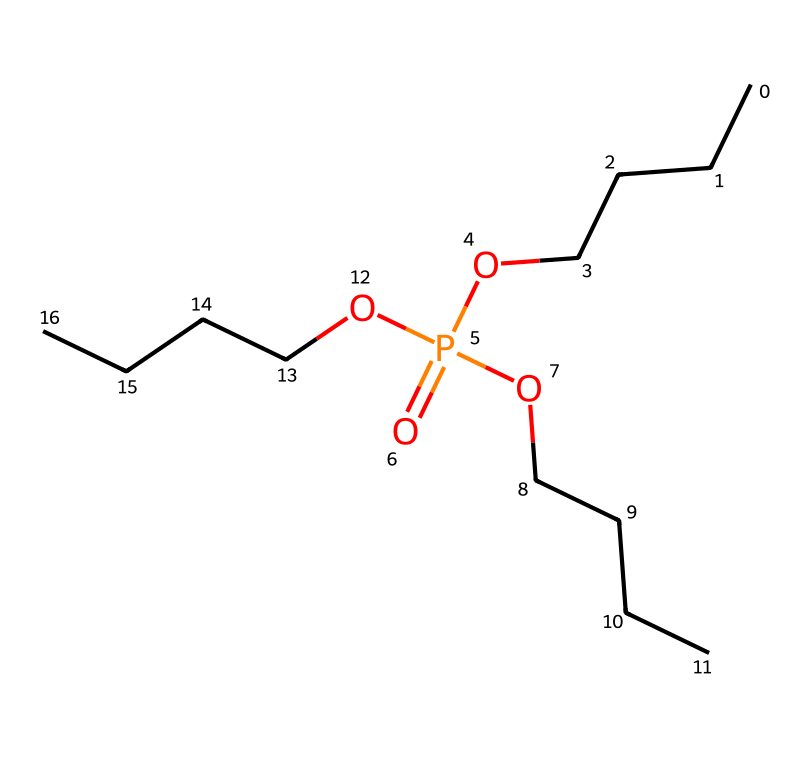How many carbon atoms are in this chemical? By analyzing the SMILES representation, we can count the 'C' characters. Each 'C' corresponds to a carbon atom in the structure. There are 9 carbon atoms present in total.
Answer: 9 What is the functional group present in this chemical? The presence of the 'P(=O)(O' portion indicates that there is a phosphate functional group. This group is characterized by phosphorus bonded to oxygen atoms, which is critical for its properties.
Answer: phosphate What type of chemical bond connects the carbon atoms in this structure? The structure clearly shows that carbon atoms are primarily connected by single bonds, as seen by the lack of double or triple bond indicators between the 'C' symbols.
Answer: single bonds What is the role of the phosphate group in this chemical? The phosphate group in hydraulic fluids typically enhances fire resistance due to its ability to form stable bonds and reduce flammability. It is crucial for the functionality of the hydraulic fluid under high temperatures.
Answer: fire resistance What makes this hydraulic fluid suitable for firefighting applications? The presence of the phosphate group along with the carbon chains helps provide thermal stability and lubrication in extreme conditions, which is essential for firefighting equipment. These properties enable effective performance despite high heat exposure.
Answer: thermal stability How many oxygen atoms are in this chemical? In the given SMILES representation, the 'O' symbols can be counted. There are 4 oxygen atoms, indicated by their presence in the structure.
Answer: 4 What does the phosphate group's structure contribute to in this chemical? The phosphate group provides unique properties like high thermal stability and water solubility, which are critical for hydraulic fluids used in extreme firefighting conditions, allowing for efficient operation.
Answer: unique properties 